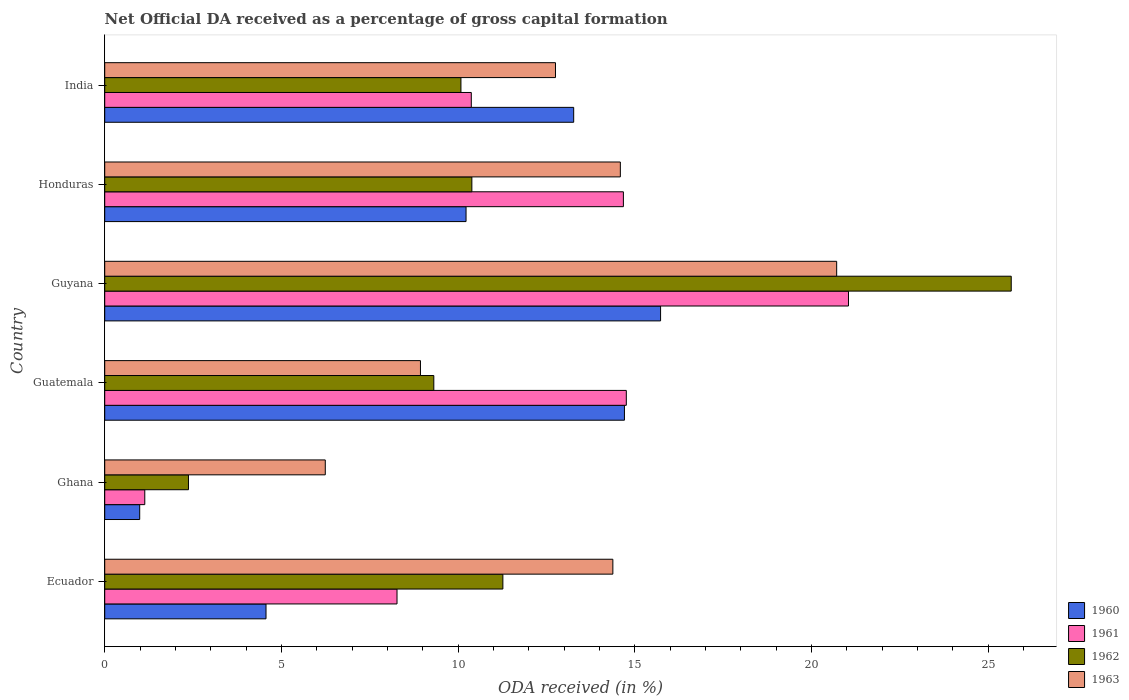How many different coloured bars are there?
Your response must be concise. 4. How many groups of bars are there?
Your response must be concise. 6. Are the number of bars per tick equal to the number of legend labels?
Make the answer very short. Yes. How many bars are there on the 6th tick from the bottom?
Ensure brevity in your answer.  4. What is the net ODA received in 1963 in Honduras?
Your response must be concise. 14.59. Across all countries, what is the maximum net ODA received in 1962?
Offer a terse response. 25.65. Across all countries, what is the minimum net ODA received in 1961?
Offer a terse response. 1.13. In which country was the net ODA received in 1962 maximum?
Give a very brief answer. Guyana. What is the total net ODA received in 1960 in the graph?
Your answer should be very brief. 59.49. What is the difference between the net ODA received in 1962 in Ghana and that in Guatemala?
Provide a succinct answer. -6.94. What is the difference between the net ODA received in 1962 in Ghana and the net ODA received in 1961 in Ecuador?
Ensure brevity in your answer.  -5.9. What is the average net ODA received in 1961 per country?
Offer a very short reply. 11.71. What is the difference between the net ODA received in 1963 and net ODA received in 1962 in Ecuador?
Provide a succinct answer. 3.11. What is the ratio of the net ODA received in 1961 in Ghana to that in India?
Provide a succinct answer. 0.11. What is the difference between the highest and the second highest net ODA received in 1963?
Your response must be concise. 6.12. What is the difference between the highest and the lowest net ODA received in 1960?
Offer a terse response. 14.74. Is it the case that in every country, the sum of the net ODA received in 1962 and net ODA received in 1960 is greater than the sum of net ODA received in 1963 and net ODA received in 1961?
Give a very brief answer. No. What does the 1st bar from the top in India represents?
Offer a very short reply. 1963. What does the 4th bar from the bottom in Honduras represents?
Your answer should be compact. 1963. Are all the bars in the graph horizontal?
Give a very brief answer. Yes. Does the graph contain grids?
Offer a very short reply. No. Where does the legend appear in the graph?
Give a very brief answer. Bottom right. How are the legend labels stacked?
Your answer should be very brief. Vertical. What is the title of the graph?
Ensure brevity in your answer.  Net Official DA received as a percentage of gross capital formation. Does "1984" appear as one of the legend labels in the graph?
Give a very brief answer. No. What is the label or title of the X-axis?
Offer a terse response. ODA received (in %). What is the ODA received (in %) in 1960 in Ecuador?
Your answer should be compact. 4.56. What is the ODA received (in %) in 1961 in Ecuador?
Your response must be concise. 8.27. What is the ODA received (in %) in 1962 in Ecuador?
Keep it short and to the point. 11.27. What is the ODA received (in %) of 1963 in Ecuador?
Make the answer very short. 14.38. What is the ODA received (in %) in 1960 in Ghana?
Offer a very short reply. 0.99. What is the ODA received (in %) of 1961 in Ghana?
Give a very brief answer. 1.13. What is the ODA received (in %) in 1962 in Ghana?
Your answer should be very brief. 2.37. What is the ODA received (in %) in 1963 in Ghana?
Offer a terse response. 6.24. What is the ODA received (in %) in 1960 in Guatemala?
Provide a succinct answer. 14.71. What is the ODA received (in %) in 1961 in Guatemala?
Your response must be concise. 14.76. What is the ODA received (in %) in 1962 in Guatemala?
Provide a succinct answer. 9.31. What is the ODA received (in %) in 1963 in Guatemala?
Your answer should be compact. 8.93. What is the ODA received (in %) in 1960 in Guyana?
Offer a terse response. 15.73. What is the ODA received (in %) of 1961 in Guyana?
Keep it short and to the point. 21.05. What is the ODA received (in %) in 1962 in Guyana?
Your answer should be very brief. 25.65. What is the ODA received (in %) in 1963 in Guyana?
Ensure brevity in your answer.  20.71. What is the ODA received (in %) in 1960 in Honduras?
Ensure brevity in your answer.  10.23. What is the ODA received (in %) in 1961 in Honduras?
Offer a very short reply. 14.68. What is the ODA received (in %) of 1962 in Honduras?
Offer a terse response. 10.39. What is the ODA received (in %) in 1963 in Honduras?
Ensure brevity in your answer.  14.59. What is the ODA received (in %) of 1960 in India?
Keep it short and to the point. 13.27. What is the ODA received (in %) of 1961 in India?
Your answer should be compact. 10.37. What is the ODA received (in %) in 1962 in India?
Provide a succinct answer. 10.08. What is the ODA received (in %) in 1963 in India?
Provide a short and direct response. 12.76. Across all countries, what is the maximum ODA received (in %) of 1960?
Keep it short and to the point. 15.73. Across all countries, what is the maximum ODA received (in %) of 1961?
Provide a short and direct response. 21.05. Across all countries, what is the maximum ODA received (in %) of 1962?
Your answer should be compact. 25.65. Across all countries, what is the maximum ODA received (in %) of 1963?
Your answer should be compact. 20.71. Across all countries, what is the minimum ODA received (in %) in 1960?
Provide a short and direct response. 0.99. Across all countries, what is the minimum ODA received (in %) in 1961?
Offer a terse response. 1.13. Across all countries, what is the minimum ODA received (in %) in 1962?
Make the answer very short. 2.37. Across all countries, what is the minimum ODA received (in %) in 1963?
Ensure brevity in your answer.  6.24. What is the total ODA received (in %) of 1960 in the graph?
Provide a short and direct response. 59.49. What is the total ODA received (in %) in 1961 in the graph?
Give a very brief answer. 70.26. What is the total ODA received (in %) of 1962 in the graph?
Ensure brevity in your answer.  69.07. What is the total ODA received (in %) in 1963 in the graph?
Provide a short and direct response. 77.62. What is the difference between the ODA received (in %) in 1960 in Ecuador and that in Ghana?
Your answer should be very brief. 3.57. What is the difference between the ODA received (in %) of 1961 in Ecuador and that in Ghana?
Offer a very short reply. 7.14. What is the difference between the ODA received (in %) of 1962 in Ecuador and that in Ghana?
Your answer should be compact. 8.9. What is the difference between the ODA received (in %) of 1963 in Ecuador and that in Ghana?
Keep it short and to the point. 8.14. What is the difference between the ODA received (in %) in 1960 in Ecuador and that in Guatemala?
Make the answer very short. -10.14. What is the difference between the ODA received (in %) in 1961 in Ecuador and that in Guatemala?
Make the answer very short. -6.49. What is the difference between the ODA received (in %) in 1962 in Ecuador and that in Guatemala?
Keep it short and to the point. 1.95. What is the difference between the ODA received (in %) in 1963 in Ecuador and that in Guatemala?
Your answer should be very brief. 5.44. What is the difference between the ODA received (in %) of 1960 in Ecuador and that in Guyana?
Your answer should be compact. -11.17. What is the difference between the ODA received (in %) in 1961 in Ecuador and that in Guyana?
Provide a succinct answer. -12.78. What is the difference between the ODA received (in %) of 1962 in Ecuador and that in Guyana?
Offer a very short reply. -14.39. What is the difference between the ODA received (in %) of 1963 in Ecuador and that in Guyana?
Offer a terse response. -6.33. What is the difference between the ODA received (in %) of 1960 in Ecuador and that in Honduras?
Your answer should be very brief. -5.66. What is the difference between the ODA received (in %) of 1961 in Ecuador and that in Honduras?
Make the answer very short. -6.41. What is the difference between the ODA received (in %) in 1962 in Ecuador and that in Honduras?
Give a very brief answer. 0.88. What is the difference between the ODA received (in %) of 1963 in Ecuador and that in Honduras?
Offer a terse response. -0.21. What is the difference between the ODA received (in %) of 1960 in Ecuador and that in India?
Your response must be concise. -8.71. What is the difference between the ODA received (in %) in 1961 in Ecuador and that in India?
Make the answer very short. -2.1. What is the difference between the ODA received (in %) of 1962 in Ecuador and that in India?
Offer a terse response. 1.19. What is the difference between the ODA received (in %) in 1963 in Ecuador and that in India?
Offer a terse response. 1.62. What is the difference between the ODA received (in %) of 1960 in Ghana and that in Guatemala?
Offer a very short reply. -13.72. What is the difference between the ODA received (in %) of 1961 in Ghana and that in Guatemala?
Provide a short and direct response. -13.63. What is the difference between the ODA received (in %) of 1962 in Ghana and that in Guatemala?
Your response must be concise. -6.94. What is the difference between the ODA received (in %) of 1963 in Ghana and that in Guatemala?
Your answer should be very brief. -2.69. What is the difference between the ODA received (in %) of 1960 in Ghana and that in Guyana?
Provide a succinct answer. -14.74. What is the difference between the ODA received (in %) in 1961 in Ghana and that in Guyana?
Your answer should be very brief. -19.91. What is the difference between the ODA received (in %) of 1962 in Ghana and that in Guyana?
Give a very brief answer. -23.28. What is the difference between the ODA received (in %) in 1963 in Ghana and that in Guyana?
Your answer should be very brief. -14.47. What is the difference between the ODA received (in %) in 1960 in Ghana and that in Honduras?
Provide a succinct answer. -9.23. What is the difference between the ODA received (in %) in 1961 in Ghana and that in Honduras?
Make the answer very short. -13.54. What is the difference between the ODA received (in %) of 1962 in Ghana and that in Honduras?
Offer a terse response. -8.02. What is the difference between the ODA received (in %) of 1963 in Ghana and that in Honduras?
Your response must be concise. -8.35. What is the difference between the ODA received (in %) in 1960 in Ghana and that in India?
Provide a succinct answer. -12.28. What is the difference between the ODA received (in %) in 1961 in Ghana and that in India?
Offer a very short reply. -9.24. What is the difference between the ODA received (in %) in 1962 in Ghana and that in India?
Offer a terse response. -7.71. What is the difference between the ODA received (in %) in 1963 in Ghana and that in India?
Ensure brevity in your answer.  -6.51. What is the difference between the ODA received (in %) in 1960 in Guatemala and that in Guyana?
Your answer should be very brief. -1.02. What is the difference between the ODA received (in %) in 1961 in Guatemala and that in Guyana?
Your answer should be very brief. -6.29. What is the difference between the ODA received (in %) of 1962 in Guatemala and that in Guyana?
Provide a succinct answer. -16.34. What is the difference between the ODA received (in %) in 1963 in Guatemala and that in Guyana?
Ensure brevity in your answer.  -11.78. What is the difference between the ODA received (in %) of 1960 in Guatemala and that in Honduras?
Provide a short and direct response. 4.48. What is the difference between the ODA received (in %) in 1961 in Guatemala and that in Honduras?
Offer a very short reply. 0.08. What is the difference between the ODA received (in %) of 1962 in Guatemala and that in Honduras?
Ensure brevity in your answer.  -1.08. What is the difference between the ODA received (in %) in 1963 in Guatemala and that in Honduras?
Provide a succinct answer. -5.66. What is the difference between the ODA received (in %) in 1960 in Guatemala and that in India?
Give a very brief answer. 1.44. What is the difference between the ODA received (in %) in 1961 in Guatemala and that in India?
Provide a succinct answer. 4.39. What is the difference between the ODA received (in %) in 1962 in Guatemala and that in India?
Your response must be concise. -0.77. What is the difference between the ODA received (in %) in 1963 in Guatemala and that in India?
Your response must be concise. -3.82. What is the difference between the ODA received (in %) of 1960 in Guyana and that in Honduras?
Your response must be concise. 5.5. What is the difference between the ODA received (in %) of 1961 in Guyana and that in Honduras?
Make the answer very short. 6.37. What is the difference between the ODA received (in %) of 1962 in Guyana and that in Honduras?
Your answer should be compact. 15.26. What is the difference between the ODA received (in %) in 1963 in Guyana and that in Honduras?
Your answer should be very brief. 6.12. What is the difference between the ODA received (in %) of 1960 in Guyana and that in India?
Your response must be concise. 2.46. What is the difference between the ODA received (in %) in 1961 in Guyana and that in India?
Your answer should be very brief. 10.67. What is the difference between the ODA received (in %) in 1962 in Guyana and that in India?
Make the answer very short. 15.57. What is the difference between the ODA received (in %) in 1963 in Guyana and that in India?
Offer a terse response. 7.96. What is the difference between the ODA received (in %) of 1960 in Honduras and that in India?
Provide a succinct answer. -3.05. What is the difference between the ODA received (in %) of 1961 in Honduras and that in India?
Give a very brief answer. 4.3. What is the difference between the ODA received (in %) in 1962 in Honduras and that in India?
Offer a very short reply. 0.31. What is the difference between the ODA received (in %) of 1963 in Honduras and that in India?
Provide a succinct answer. 1.84. What is the difference between the ODA received (in %) of 1960 in Ecuador and the ODA received (in %) of 1961 in Ghana?
Your response must be concise. 3.43. What is the difference between the ODA received (in %) of 1960 in Ecuador and the ODA received (in %) of 1962 in Ghana?
Give a very brief answer. 2.19. What is the difference between the ODA received (in %) of 1960 in Ecuador and the ODA received (in %) of 1963 in Ghana?
Ensure brevity in your answer.  -1.68. What is the difference between the ODA received (in %) in 1961 in Ecuador and the ODA received (in %) in 1962 in Ghana?
Give a very brief answer. 5.9. What is the difference between the ODA received (in %) of 1961 in Ecuador and the ODA received (in %) of 1963 in Ghana?
Make the answer very short. 2.03. What is the difference between the ODA received (in %) in 1962 in Ecuador and the ODA received (in %) in 1963 in Ghana?
Provide a short and direct response. 5.03. What is the difference between the ODA received (in %) of 1960 in Ecuador and the ODA received (in %) of 1961 in Guatemala?
Your answer should be compact. -10.2. What is the difference between the ODA received (in %) of 1960 in Ecuador and the ODA received (in %) of 1962 in Guatemala?
Make the answer very short. -4.75. What is the difference between the ODA received (in %) in 1960 in Ecuador and the ODA received (in %) in 1963 in Guatemala?
Make the answer very short. -4.37. What is the difference between the ODA received (in %) of 1961 in Ecuador and the ODA received (in %) of 1962 in Guatemala?
Your answer should be very brief. -1.04. What is the difference between the ODA received (in %) of 1961 in Ecuador and the ODA received (in %) of 1963 in Guatemala?
Provide a succinct answer. -0.66. What is the difference between the ODA received (in %) of 1962 in Ecuador and the ODA received (in %) of 1963 in Guatemala?
Your response must be concise. 2.33. What is the difference between the ODA received (in %) in 1960 in Ecuador and the ODA received (in %) in 1961 in Guyana?
Make the answer very short. -16.48. What is the difference between the ODA received (in %) in 1960 in Ecuador and the ODA received (in %) in 1962 in Guyana?
Provide a short and direct response. -21.09. What is the difference between the ODA received (in %) of 1960 in Ecuador and the ODA received (in %) of 1963 in Guyana?
Offer a terse response. -16.15. What is the difference between the ODA received (in %) of 1961 in Ecuador and the ODA received (in %) of 1962 in Guyana?
Give a very brief answer. -17.38. What is the difference between the ODA received (in %) of 1961 in Ecuador and the ODA received (in %) of 1963 in Guyana?
Make the answer very short. -12.44. What is the difference between the ODA received (in %) of 1962 in Ecuador and the ODA received (in %) of 1963 in Guyana?
Give a very brief answer. -9.45. What is the difference between the ODA received (in %) in 1960 in Ecuador and the ODA received (in %) in 1961 in Honduras?
Offer a very short reply. -10.11. What is the difference between the ODA received (in %) in 1960 in Ecuador and the ODA received (in %) in 1962 in Honduras?
Offer a very short reply. -5.83. What is the difference between the ODA received (in %) of 1960 in Ecuador and the ODA received (in %) of 1963 in Honduras?
Your answer should be very brief. -10.03. What is the difference between the ODA received (in %) in 1961 in Ecuador and the ODA received (in %) in 1962 in Honduras?
Your response must be concise. -2.12. What is the difference between the ODA received (in %) in 1961 in Ecuador and the ODA received (in %) in 1963 in Honduras?
Provide a succinct answer. -6.32. What is the difference between the ODA received (in %) in 1962 in Ecuador and the ODA received (in %) in 1963 in Honduras?
Your answer should be compact. -3.32. What is the difference between the ODA received (in %) in 1960 in Ecuador and the ODA received (in %) in 1961 in India?
Offer a very short reply. -5.81. What is the difference between the ODA received (in %) of 1960 in Ecuador and the ODA received (in %) of 1962 in India?
Provide a succinct answer. -5.52. What is the difference between the ODA received (in %) of 1960 in Ecuador and the ODA received (in %) of 1963 in India?
Provide a short and direct response. -8.19. What is the difference between the ODA received (in %) in 1961 in Ecuador and the ODA received (in %) in 1962 in India?
Your answer should be very brief. -1.81. What is the difference between the ODA received (in %) in 1961 in Ecuador and the ODA received (in %) in 1963 in India?
Offer a terse response. -4.48. What is the difference between the ODA received (in %) of 1962 in Ecuador and the ODA received (in %) of 1963 in India?
Offer a terse response. -1.49. What is the difference between the ODA received (in %) of 1960 in Ghana and the ODA received (in %) of 1961 in Guatemala?
Your answer should be compact. -13.77. What is the difference between the ODA received (in %) in 1960 in Ghana and the ODA received (in %) in 1962 in Guatemala?
Ensure brevity in your answer.  -8.32. What is the difference between the ODA received (in %) of 1960 in Ghana and the ODA received (in %) of 1963 in Guatemala?
Ensure brevity in your answer.  -7.94. What is the difference between the ODA received (in %) in 1961 in Ghana and the ODA received (in %) in 1962 in Guatemala?
Offer a very short reply. -8.18. What is the difference between the ODA received (in %) in 1961 in Ghana and the ODA received (in %) in 1963 in Guatemala?
Your answer should be very brief. -7.8. What is the difference between the ODA received (in %) of 1962 in Ghana and the ODA received (in %) of 1963 in Guatemala?
Provide a succinct answer. -6.56. What is the difference between the ODA received (in %) in 1960 in Ghana and the ODA received (in %) in 1961 in Guyana?
Your answer should be compact. -20.06. What is the difference between the ODA received (in %) in 1960 in Ghana and the ODA received (in %) in 1962 in Guyana?
Offer a terse response. -24.66. What is the difference between the ODA received (in %) in 1960 in Ghana and the ODA received (in %) in 1963 in Guyana?
Make the answer very short. -19.72. What is the difference between the ODA received (in %) of 1961 in Ghana and the ODA received (in %) of 1962 in Guyana?
Keep it short and to the point. -24.52. What is the difference between the ODA received (in %) in 1961 in Ghana and the ODA received (in %) in 1963 in Guyana?
Offer a terse response. -19.58. What is the difference between the ODA received (in %) in 1962 in Ghana and the ODA received (in %) in 1963 in Guyana?
Provide a short and direct response. -18.34. What is the difference between the ODA received (in %) of 1960 in Ghana and the ODA received (in %) of 1961 in Honduras?
Keep it short and to the point. -13.69. What is the difference between the ODA received (in %) in 1960 in Ghana and the ODA received (in %) in 1962 in Honduras?
Your answer should be very brief. -9.4. What is the difference between the ODA received (in %) in 1960 in Ghana and the ODA received (in %) in 1963 in Honduras?
Give a very brief answer. -13.6. What is the difference between the ODA received (in %) in 1961 in Ghana and the ODA received (in %) in 1962 in Honduras?
Keep it short and to the point. -9.26. What is the difference between the ODA received (in %) of 1961 in Ghana and the ODA received (in %) of 1963 in Honduras?
Your response must be concise. -13.46. What is the difference between the ODA received (in %) of 1962 in Ghana and the ODA received (in %) of 1963 in Honduras?
Your answer should be compact. -12.22. What is the difference between the ODA received (in %) in 1960 in Ghana and the ODA received (in %) in 1961 in India?
Your answer should be compact. -9.38. What is the difference between the ODA received (in %) in 1960 in Ghana and the ODA received (in %) in 1962 in India?
Your answer should be very brief. -9.09. What is the difference between the ODA received (in %) of 1960 in Ghana and the ODA received (in %) of 1963 in India?
Provide a succinct answer. -11.77. What is the difference between the ODA received (in %) of 1961 in Ghana and the ODA received (in %) of 1962 in India?
Keep it short and to the point. -8.95. What is the difference between the ODA received (in %) in 1961 in Ghana and the ODA received (in %) in 1963 in India?
Provide a succinct answer. -11.62. What is the difference between the ODA received (in %) in 1962 in Ghana and the ODA received (in %) in 1963 in India?
Give a very brief answer. -10.39. What is the difference between the ODA received (in %) in 1960 in Guatemala and the ODA received (in %) in 1961 in Guyana?
Give a very brief answer. -6.34. What is the difference between the ODA received (in %) of 1960 in Guatemala and the ODA received (in %) of 1962 in Guyana?
Give a very brief answer. -10.95. What is the difference between the ODA received (in %) of 1960 in Guatemala and the ODA received (in %) of 1963 in Guyana?
Offer a very short reply. -6.01. What is the difference between the ODA received (in %) in 1961 in Guatemala and the ODA received (in %) in 1962 in Guyana?
Ensure brevity in your answer.  -10.89. What is the difference between the ODA received (in %) in 1961 in Guatemala and the ODA received (in %) in 1963 in Guyana?
Offer a very short reply. -5.95. What is the difference between the ODA received (in %) in 1962 in Guatemala and the ODA received (in %) in 1963 in Guyana?
Keep it short and to the point. -11.4. What is the difference between the ODA received (in %) in 1960 in Guatemala and the ODA received (in %) in 1961 in Honduras?
Keep it short and to the point. 0.03. What is the difference between the ODA received (in %) of 1960 in Guatemala and the ODA received (in %) of 1962 in Honduras?
Provide a short and direct response. 4.32. What is the difference between the ODA received (in %) in 1960 in Guatemala and the ODA received (in %) in 1963 in Honduras?
Offer a very short reply. 0.12. What is the difference between the ODA received (in %) in 1961 in Guatemala and the ODA received (in %) in 1962 in Honduras?
Make the answer very short. 4.37. What is the difference between the ODA received (in %) in 1961 in Guatemala and the ODA received (in %) in 1963 in Honduras?
Offer a terse response. 0.17. What is the difference between the ODA received (in %) in 1962 in Guatemala and the ODA received (in %) in 1963 in Honduras?
Provide a short and direct response. -5.28. What is the difference between the ODA received (in %) of 1960 in Guatemala and the ODA received (in %) of 1961 in India?
Give a very brief answer. 4.33. What is the difference between the ODA received (in %) in 1960 in Guatemala and the ODA received (in %) in 1962 in India?
Provide a succinct answer. 4.63. What is the difference between the ODA received (in %) in 1960 in Guatemala and the ODA received (in %) in 1963 in India?
Make the answer very short. 1.95. What is the difference between the ODA received (in %) in 1961 in Guatemala and the ODA received (in %) in 1962 in India?
Offer a very short reply. 4.68. What is the difference between the ODA received (in %) of 1961 in Guatemala and the ODA received (in %) of 1963 in India?
Your response must be concise. 2. What is the difference between the ODA received (in %) of 1962 in Guatemala and the ODA received (in %) of 1963 in India?
Give a very brief answer. -3.44. What is the difference between the ODA received (in %) in 1960 in Guyana and the ODA received (in %) in 1961 in Honduras?
Provide a succinct answer. 1.05. What is the difference between the ODA received (in %) of 1960 in Guyana and the ODA received (in %) of 1962 in Honduras?
Keep it short and to the point. 5.34. What is the difference between the ODA received (in %) in 1960 in Guyana and the ODA received (in %) in 1963 in Honduras?
Provide a short and direct response. 1.14. What is the difference between the ODA received (in %) in 1961 in Guyana and the ODA received (in %) in 1962 in Honduras?
Offer a terse response. 10.66. What is the difference between the ODA received (in %) in 1961 in Guyana and the ODA received (in %) in 1963 in Honduras?
Make the answer very short. 6.46. What is the difference between the ODA received (in %) of 1962 in Guyana and the ODA received (in %) of 1963 in Honduras?
Provide a short and direct response. 11.06. What is the difference between the ODA received (in %) of 1960 in Guyana and the ODA received (in %) of 1961 in India?
Your answer should be very brief. 5.36. What is the difference between the ODA received (in %) in 1960 in Guyana and the ODA received (in %) in 1962 in India?
Keep it short and to the point. 5.65. What is the difference between the ODA received (in %) in 1960 in Guyana and the ODA received (in %) in 1963 in India?
Provide a succinct answer. 2.97. What is the difference between the ODA received (in %) in 1961 in Guyana and the ODA received (in %) in 1962 in India?
Give a very brief answer. 10.97. What is the difference between the ODA received (in %) in 1961 in Guyana and the ODA received (in %) in 1963 in India?
Provide a succinct answer. 8.29. What is the difference between the ODA received (in %) in 1962 in Guyana and the ODA received (in %) in 1963 in India?
Provide a succinct answer. 12.9. What is the difference between the ODA received (in %) of 1960 in Honduras and the ODA received (in %) of 1961 in India?
Give a very brief answer. -0.15. What is the difference between the ODA received (in %) of 1960 in Honduras and the ODA received (in %) of 1962 in India?
Give a very brief answer. 0.14. What is the difference between the ODA received (in %) in 1960 in Honduras and the ODA received (in %) in 1963 in India?
Keep it short and to the point. -2.53. What is the difference between the ODA received (in %) in 1961 in Honduras and the ODA received (in %) in 1962 in India?
Keep it short and to the point. 4.6. What is the difference between the ODA received (in %) of 1961 in Honduras and the ODA received (in %) of 1963 in India?
Provide a short and direct response. 1.92. What is the difference between the ODA received (in %) of 1962 in Honduras and the ODA received (in %) of 1963 in India?
Ensure brevity in your answer.  -2.37. What is the average ODA received (in %) of 1960 per country?
Provide a succinct answer. 9.91. What is the average ODA received (in %) in 1961 per country?
Your answer should be very brief. 11.71. What is the average ODA received (in %) in 1962 per country?
Offer a very short reply. 11.51. What is the average ODA received (in %) in 1963 per country?
Your answer should be very brief. 12.94. What is the difference between the ODA received (in %) of 1960 and ODA received (in %) of 1961 in Ecuador?
Give a very brief answer. -3.71. What is the difference between the ODA received (in %) in 1960 and ODA received (in %) in 1962 in Ecuador?
Ensure brevity in your answer.  -6.7. What is the difference between the ODA received (in %) of 1960 and ODA received (in %) of 1963 in Ecuador?
Make the answer very short. -9.81. What is the difference between the ODA received (in %) of 1961 and ODA received (in %) of 1962 in Ecuador?
Provide a succinct answer. -3. What is the difference between the ODA received (in %) of 1961 and ODA received (in %) of 1963 in Ecuador?
Your answer should be very brief. -6.11. What is the difference between the ODA received (in %) of 1962 and ODA received (in %) of 1963 in Ecuador?
Provide a short and direct response. -3.11. What is the difference between the ODA received (in %) in 1960 and ODA received (in %) in 1961 in Ghana?
Provide a short and direct response. -0.14. What is the difference between the ODA received (in %) in 1960 and ODA received (in %) in 1962 in Ghana?
Offer a very short reply. -1.38. What is the difference between the ODA received (in %) of 1960 and ODA received (in %) of 1963 in Ghana?
Ensure brevity in your answer.  -5.25. What is the difference between the ODA received (in %) of 1961 and ODA received (in %) of 1962 in Ghana?
Offer a very short reply. -1.24. What is the difference between the ODA received (in %) in 1961 and ODA received (in %) in 1963 in Ghana?
Your answer should be compact. -5.11. What is the difference between the ODA received (in %) of 1962 and ODA received (in %) of 1963 in Ghana?
Your answer should be compact. -3.87. What is the difference between the ODA received (in %) in 1960 and ODA received (in %) in 1961 in Guatemala?
Offer a terse response. -0.05. What is the difference between the ODA received (in %) of 1960 and ODA received (in %) of 1962 in Guatemala?
Ensure brevity in your answer.  5.39. What is the difference between the ODA received (in %) in 1960 and ODA received (in %) in 1963 in Guatemala?
Your answer should be very brief. 5.77. What is the difference between the ODA received (in %) of 1961 and ODA received (in %) of 1962 in Guatemala?
Provide a succinct answer. 5.45. What is the difference between the ODA received (in %) in 1961 and ODA received (in %) in 1963 in Guatemala?
Your answer should be compact. 5.83. What is the difference between the ODA received (in %) of 1962 and ODA received (in %) of 1963 in Guatemala?
Offer a terse response. 0.38. What is the difference between the ODA received (in %) of 1960 and ODA received (in %) of 1961 in Guyana?
Offer a very short reply. -5.32. What is the difference between the ODA received (in %) in 1960 and ODA received (in %) in 1962 in Guyana?
Your response must be concise. -9.92. What is the difference between the ODA received (in %) in 1960 and ODA received (in %) in 1963 in Guyana?
Your response must be concise. -4.98. What is the difference between the ODA received (in %) of 1961 and ODA received (in %) of 1962 in Guyana?
Provide a short and direct response. -4.61. What is the difference between the ODA received (in %) of 1961 and ODA received (in %) of 1963 in Guyana?
Give a very brief answer. 0.33. What is the difference between the ODA received (in %) of 1962 and ODA received (in %) of 1963 in Guyana?
Offer a very short reply. 4.94. What is the difference between the ODA received (in %) in 1960 and ODA received (in %) in 1961 in Honduras?
Provide a short and direct response. -4.45. What is the difference between the ODA received (in %) of 1960 and ODA received (in %) of 1962 in Honduras?
Provide a short and direct response. -0.16. What is the difference between the ODA received (in %) in 1960 and ODA received (in %) in 1963 in Honduras?
Give a very brief answer. -4.37. What is the difference between the ODA received (in %) in 1961 and ODA received (in %) in 1962 in Honduras?
Provide a short and direct response. 4.29. What is the difference between the ODA received (in %) in 1961 and ODA received (in %) in 1963 in Honduras?
Provide a short and direct response. 0.09. What is the difference between the ODA received (in %) in 1962 and ODA received (in %) in 1963 in Honduras?
Make the answer very short. -4.2. What is the difference between the ODA received (in %) of 1960 and ODA received (in %) of 1961 in India?
Keep it short and to the point. 2.9. What is the difference between the ODA received (in %) of 1960 and ODA received (in %) of 1962 in India?
Give a very brief answer. 3.19. What is the difference between the ODA received (in %) in 1960 and ODA received (in %) in 1963 in India?
Provide a short and direct response. 0.52. What is the difference between the ODA received (in %) in 1961 and ODA received (in %) in 1962 in India?
Offer a very short reply. 0.29. What is the difference between the ODA received (in %) in 1961 and ODA received (in %) in 1963 in India?
Provide a succinct answer. -2.38. What is the difference between the ODA received (in %) in 1962 and ODA received (in %) in 1963 in India?
Offer a terse response. -2.68. What is the ratio of the ODA received (in %) in 1960 in Ecuador to that in Ghana?
Your answer should be compact. 4.61. What is the ratio of the ODA received (in %) of 1961 in Ecuador to that in Ghana?
Your response must be concise. 7.3. What is the ratio of the ODA received (in %) of 1962 in Ecuador to that in Ghana?
Provide a short and direct response. 4.75. What is the ratio of the ODA received (in %) in 1963 in Ecuador to that in Ghana?
Ensure brevity in your answer.  2.3. What is the ratio of the ODA received (in %) of 1960 in Ecuador to that in Guatemala?
Your response must be concise. 0.31. What is the ratio of the ODA received (in %) in 1961 in Ecuador to that in Guatemala?
Make the answer very short. 0.56. What is the ratio of the ODA received (in %) in 1962 in Ecuador to that in Guatemala?
Make the answer very short. 1.21. What is the ratio of the ODA received (in %) of 1963 in Ecuador to that in Guatemala?
Offer a very short reply. 1.61. What is the ratio of the ODA received (in %) of 1960 in Ecuador to that in Guyana?
Your response must be concise. 0.29. What is the ratio of the ODA received (in %) of 1961 in Ecuador to that in Guyana?
Make the answer very short. 0.39. What is the ratio of the ODA received (in %) in 1962 in Ecuador to that in Guyana?
Keep it short and to the point. 0.44. What is the ratio of the ODA received (in %) in 1963 in Ecuador to that in Guyana?
Offer a terse response. 0.69. What is the ratio of the ODA received (in %) of 1960 in Ecuador to that in Honduras?
Ensure brevity in your answer.  0.45. What is the ratio of the ODA received (in %) in 1961 in Ecuador to that in Honduras?
Ensure brevity in your answer.  0.56. What is the ratio of the ODA received (in %) of 1962 in Ecuador to that in Honduras?
Give a very brief answer. 1.08. What is the ratio of the ODA received (in %) in 1963 in Ecuador to that in Honduras?
Keep it short and to the point. 0.99. What is the ratio of the ODA received (in %) in 1960 in Ecuador to that in India?
Give a very brief answer. 0.34. What is the ratio of the ODA received (in %) of 1961 in Ecuador to that in India?
Your response must be concise. 0.8. What is the ratio of the ODA received (in %) in 1962 in Ecuador to that in India?
Provide a succinct answer. 1.12. What is the ratio of the ODA received (in %) of 1963 in Ecuador to that in India?
Ensure brevity in your answer.  1.13. What is the ratio of the ODA received (in %) of 1960 in Ghana to that in Guatemala?
Your answer should be compact. 0.07. What is the ratio of the ODA received (in %) of 1961 in Ghana to that in Guatemala?
Your response must be concise. 0.08. What is the ratio of the ODA received (in %) in 1962 in Ghana to that in Guatemala?
Give a very brief answer. 0.25. What is the ratio of the ODA received (in %) of 1963 in Ghana to that in Guatemala?
Provide a succinct answer. 0.7. What is the ratio of the ODA received (in %) in 1960 in Ghana to that in Guyana?
Give a very brief answer. 0.06. What is the ratio of the ODA received (in %) in 1961 in Ghana to that in Guyana?
Your answer should be compact. 0.05. What is the ratio of the ODA received (in %) of 1962 in Ghana to that in Guyana?
Ensure brevity in your answer.  0.09. What is the ratio of the ODA received (in %) in 1963 in Ghana to that in Guyana?
Provide a succinct answer. 0.3. What is the ratio of the ODA received (in %) of 1960 in Ghana to that in Honduras?
Provide a short and direct response. 0.1. What is the ratio of the ODA received (in %) in 1961 in Ghana to that in Honduras?
Your response must be concise. 0.08. What is the ratio of the ODA received (in %) in 1962 in Ghana to that in Honduras?
Keep it short and to the point. 0.23. What is the ratio of the ODA received (in %) in 1963 in Ghana to that in Honduras?
Keep it short and to the point. 0.43. What is the ratio of the ODA received (in %) of 1960 in Ghana to that in India?
Your response must be concise. 0.07. What is the ratio of the ODA received (in %) of 1961 in Ghana to that in India?
Provide a short and direct response. 0.11. What is the ratio of the ODA received (in %) of 1962 in Ghana to that in India?
Your answer should be very brief. 0.24. What is the ratio of the ODA received (in %) in 1963 in Ghana to that in India?
Your answer should be compact. 0.49. What is the ratio of the ODA received (in %) of 1960 in Guatemala to that in Guyana?
Give a very brief answer. 0.94. What is the ratio of the ODA received (in %) of 1961 in Guatemala to that in Guyana?
Keep it short and to the point. 0.7. What is the ratio of the ODA received (in %) of 1962 in Guatemala to that in Guyana?
Provide a short and direct response. 0.36. What is the ratio of the ODA received (in %) in 1963 in Guatemala to that in Guyana?
Give a very brief answer. 0.43. What is the ratio of the ODA received (in %) of 1960 in Guatemala to that in Honduras?
Make the answer very short. 1.44. What is the ratio of the ODA received (in %) of 1962 in Guatemala to that in Honduras?
Your answer should be very brief. 0.9. What is the ratio of the ODA received (in %) in 1963 in Guatemala to that in Honduras?
Offer a very short reply. 0.61. What is the ratio of the ODA received (in %) in 1960 in Guatemala to that in India?
Provide a succinct answer. 1.11. What is the ratio of the ODA received (in %) in 1961 in Guatemala to that in India?
Ensure brevity in your answer.  1.42. What is the ratio of the ODA received (in %) in 1962 in Guatemala to that in India?
Your response must be concise. 0.92. What is the ratio of the ODA received (in %) in 1963 in Guatemala to that in India?
Your answer should be very brief. 0.7. What is the ratio of the ODA received (in %) in 1960 in Guyana to that in Honduras?
Your response must be concise. 1.54. What is the ratio of the ODA received (in %) in 1961 in Guyana to that in Honduras?
Your answer should be very brief. 1.43. What is the ratio of the ODA received (in %) in 1962 in Guyana to that in Honduras?
Keep it short and to the point. 2.47. What is the ratio of the ODA received (in %) in 1963 in Guyana to that in Honduras?
Your answer should be very brief. 1.42. What is the ratio of the ODA received (in %) in 1960 in Guyana to that in India?
Provide a short and direct response. 1.19. What is the ratio of the ODA received (in %) in 1961 in Guyana to that in India?
Your answer should be compact. 2.03. What is the ratio of the ODA received (in %) in 1962 in Guyana to that in India?
Make the answer very short. 2.54. What is the ratio of the ODA received (in %) in 1963 in Guyana to that in India?
Provide a short and direct response. 1.62. What is the ratio of the ODA received (in %) in 1960 in Honduras to that in India?
Provide a short and direct response. 0.77. What is the ratio of the ODA received (in %) of 1961 in Honduras to that in India?
Keep it short and to the point. 1.41. What is the ratio of the ODA received (in %) of 1962 in Honduras to that in India?
Your response must be concise. 1.03. What is the ratio of the ODA received (in %) of 1963 in Honduras to that in India?
Your answer should be compact. 1.14. What is the difference between the highest and the second highest ODA received (in %) in 1960?
Offer a terse response. 1.02. What is the difference between the highest and the second highest ODA received (in %) of 1961?
Your answer should be very brief. 6.29. What is the difference between the highest and the second highest ODA received (in %) of 1962?
Offer a terse response. 14.39. What is the difference between the highest and the second highest ODA received (in %) of 1963?
Your answer should be very brief. 6.12. What is the difference between the highest and the lowest ODA received (in %) in 1960?
Make the answer very short. 14.74. What is the difference between the highest and the lowest ODA received (in %) in 1961?
Offer a very short reply. 19.91. What is the difference between the highest and the lowest ODA received (in %) in 1962?
Ensure brevity in your answer.  23.28. What is the difference between the highest and the lowest ODA received (in %) of 1963?
Your response must be concise. 14.47. 